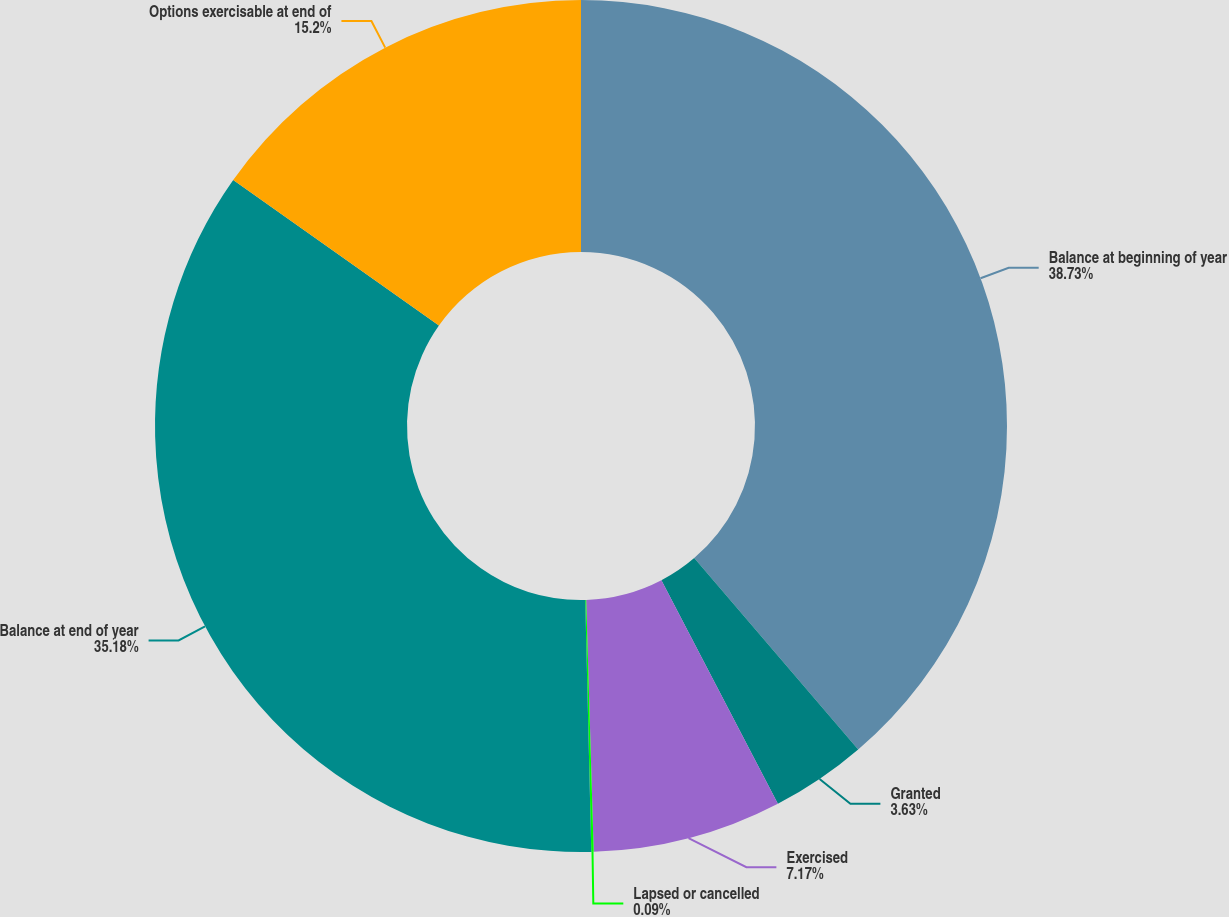Convert chart. <chart><loc_0><loc_0><loc_500><loc_500><pie_chart><fcel>Balance at beginning of year<fcel>Granted<fcel>Exercised<fcel>Lapsed or cancelled<fcel>Balance at end of year<fcel>Options exercisable at end of<nl><fcel>38.72%<fcel>3.63%<fcel>7.17%<fcel>0.09%<fcel>35.18%<fcel>15.2%<nl></chart> 